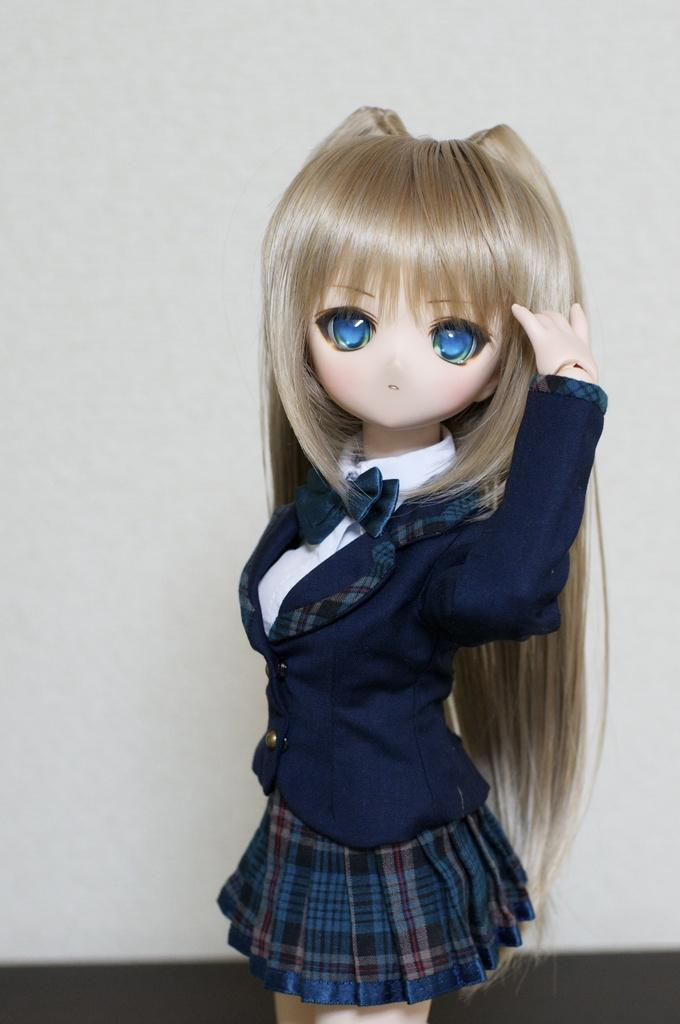What is the main subject in the middle of the image? There is a toy in the middle of the image. What color is the background of the image? The background of the image is white. What color is the bottom of the image? The bottom of the image is white. What type of yarn is being used in the story depicted in the image? There is no story or yarn present in the image; it features a toy in the middle of a white background and bottom. 